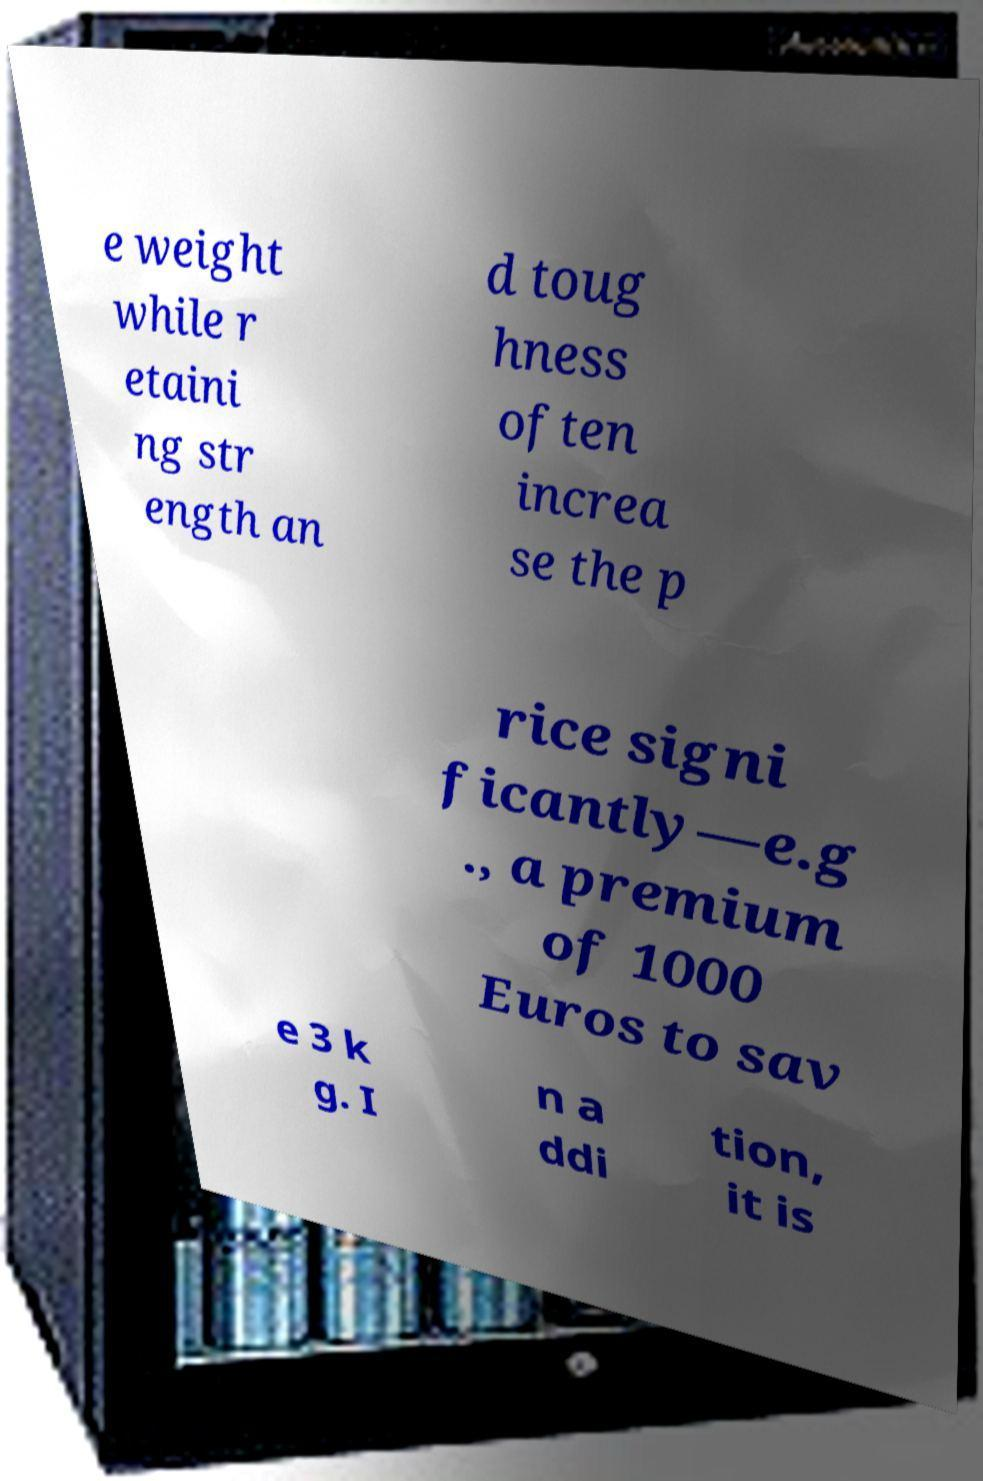For documentation purposes, I need the text within this image transcribed. Could you provide that? e weight while r etaini ng str ength an d toug hness often increa se the p rice signi ficantly—e.g ., a premium of 1000 Euros to sav e 3 k g. I n a ddi tion, it is 